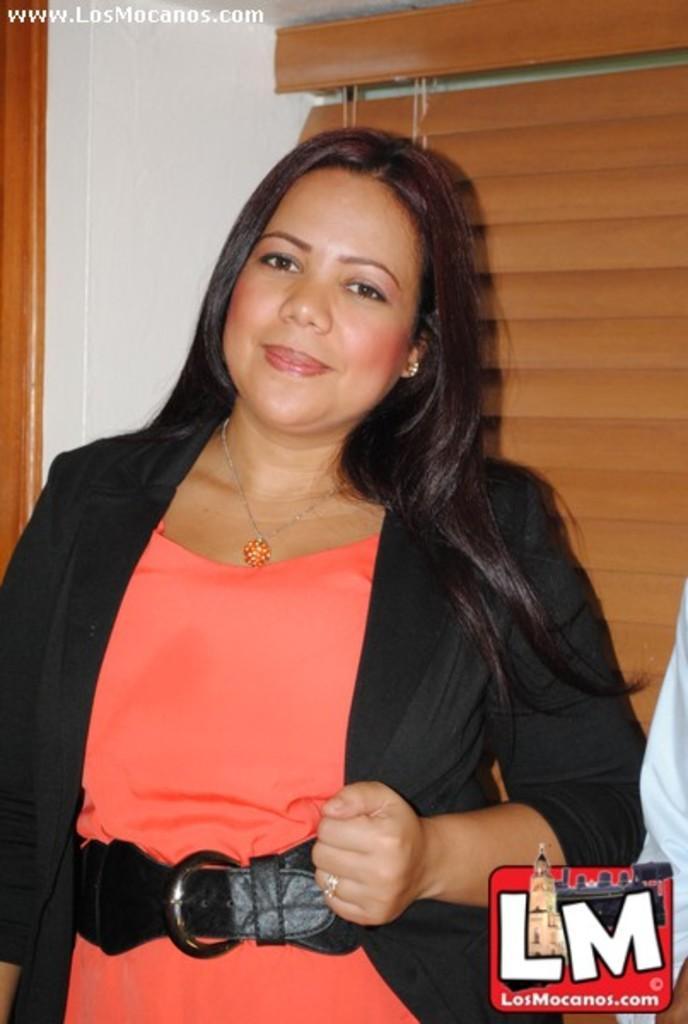Describe this image in one or two sentences. As we can see in the image there is a wall, a woman wearing black color jacket and orange color dress. 